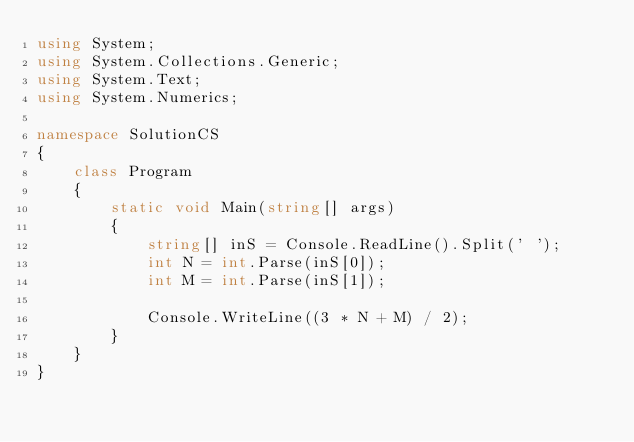Convert code to text. <code><loc_0><loc_0><loc_500><loc_500><_C#_>using System;
using System.Collections.Generic;
using System.Text;
using System.Numerics;

namespace SolutionCS
{
    class Program
    {
        static void Main(string[] args)
        {
            string[] inS = Console.ReadLine().Split(' ');
            int N = int.Parse(inS[0]);
            int M = int.Parse(inS[1]);

            Console.WriteLine((3 * N + M) / 2);
        }
    }
}
</code> 